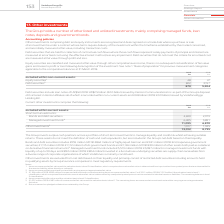From Vodafone Group Plc's financial document, Which financial years' information is shown in the table? The document shows two values: 2018 and 2019. From the document: "2019 2018 €m €m Included within non-current assets: Equity securities 1 48 47 Debt securities 2 822 3,15 2019 2018 €m €m Included within non-current a..." Also, What type of short-term investments are shown in the table? The document shows two values: Bonds and debt securities and Managed investment funds. From the document: "ed within current assets: Short-term investments: Bonds and debt securities 3 4,690 2,979 Managed investment funds 4 6,405 3,891 11,095 6,870 Other in..." Also, What is the total value of short-term investments in 2019? According to the financial document, 11,095 (in millions). The relevant text states: ",690 2,979 Managed investment funds 4 6,405 3,891 11,095 6,870 Other investments 5 1,917 1,925 13,012 8,795..." Also, can you calculate: What percentage of 2019 Bonds and debt securities is the 2019 highly liquid German government securities? Based on the calculation: 955/4,690, the result is 20.36 (percentage). This is based on the information: "ort-term investments: Bonds and debt securities 3 4,690 2,979 Managed investment funds 4 6,405 3,891 11,095 6,870 Other investments 5 1,917 1,925 13,012 8, Bonds and debt securities includes €955 mill..." The key data points involved are: 4,690, 955. Also, can you calculate: What percentage of 2019 Bonds and debt securities is the 2019 Japanese government securities? Based on the calculation: 941/4,690, the result is 20.06 (percentage). This is based on the information: "ort-term investments: Bonds and debt securities 3 4,690 2,979 Managed investment funds 4 6,405 3,891 11,095 6,870 Other investments 5 1,917 1,925 13,012 8, (2018: €862 million) of highly liquid German..." The key data points involved are: 4,690, 941. Also, can you calculate: What is the change in managed investment funds between 2018 and 2019? Based on the calculation: 6,405-3,891, the result is 2514 (in millions). This is based on the information: "curities 3 4,690 2,979 Managed investment funds 4 6,405 3,891 11,095 6,870 Other investments 5 1,917 1,925 13,012 8,795 es 3 4,690 2,979 Managed investment funds 4 6,405 3,891 11,095 6,870 Other inves..." The key data points involved are: 3,891, 6,405. 